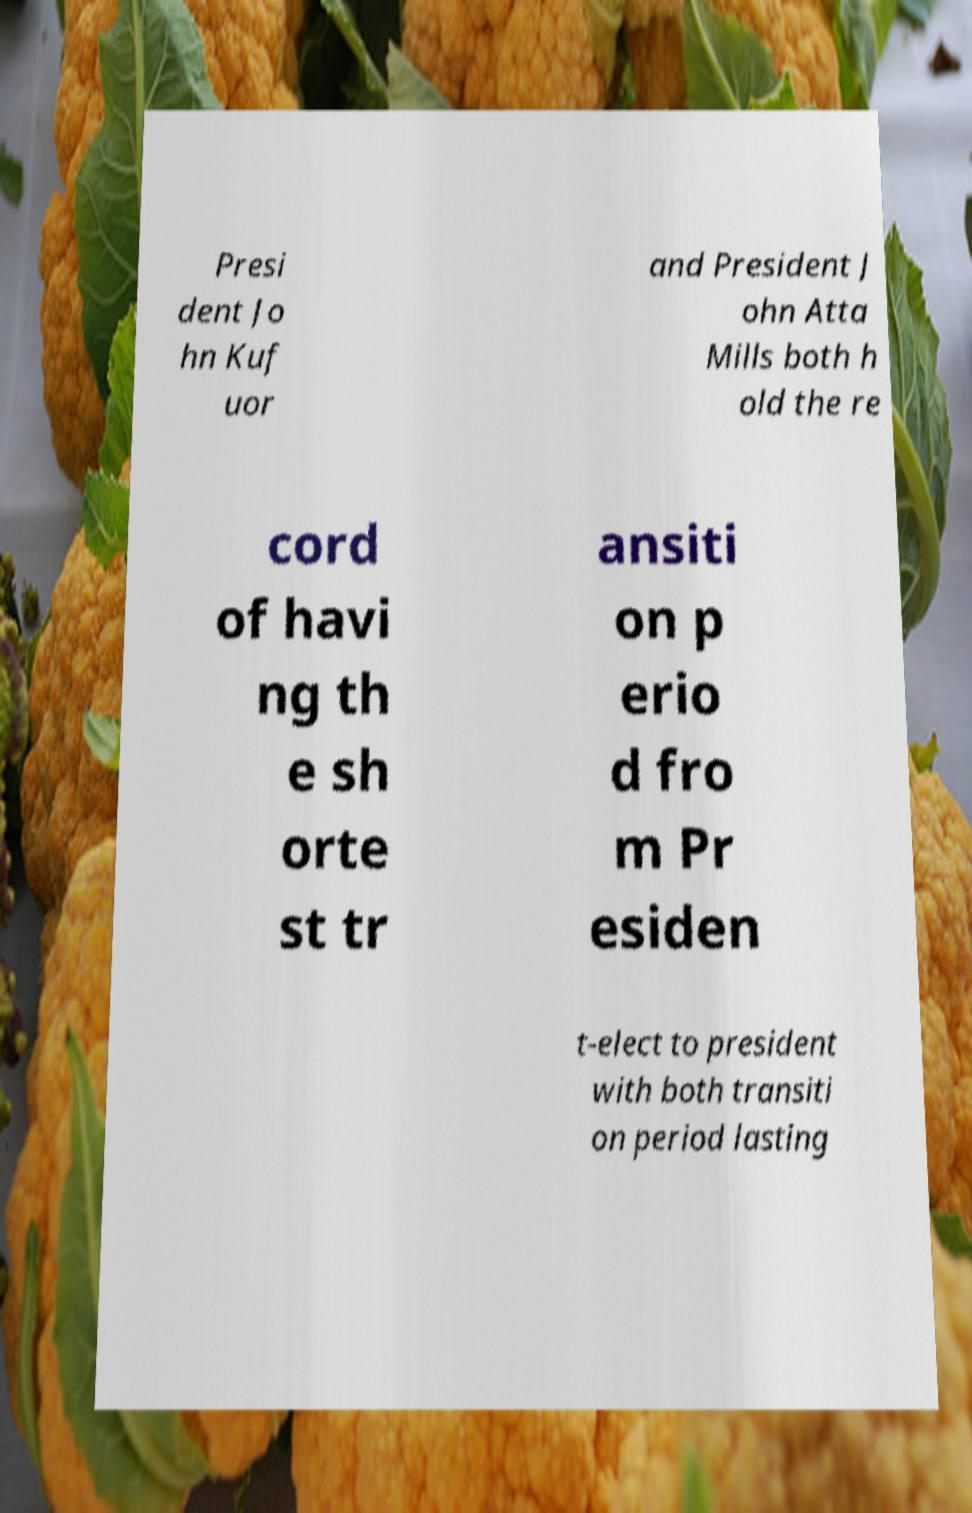Could you extract and type out the text from this image? Presi dent Jo hn Kuf uor and President J ohn Atta Mills both h old the re cord of havi ng th e sh orte st tr ansiti on p erio d fro m Pr esiden t-elect to president with both transiti on period lasting 